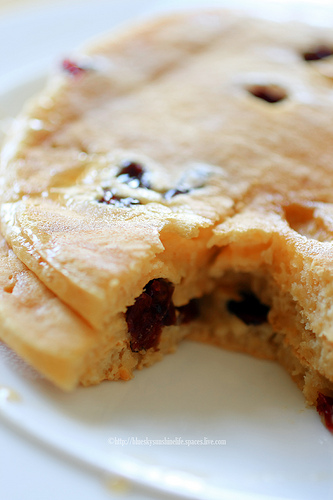<image>
Can you confirm if the raisin is in the pancake? Yes. The raisin is contained within or inside the pancake, showing a containment relationship. 